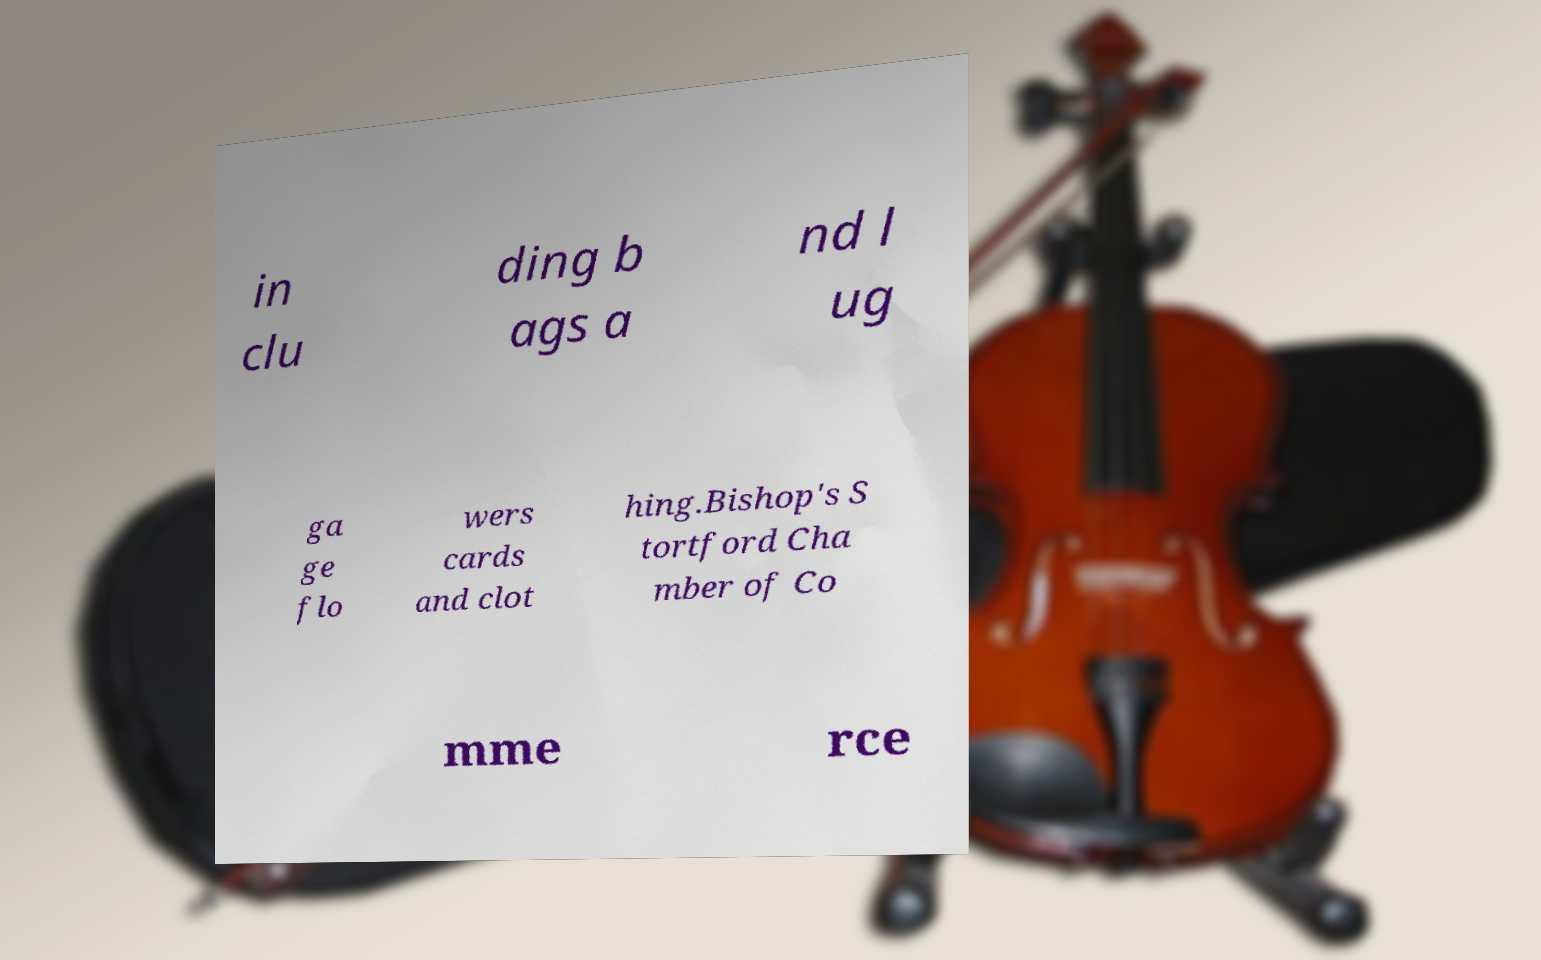Can you read and provide the text displayed in the image?This photo seems to have some interesting text. Can you extract and type it out for me? in clu ding b ags a nd l ug ga ge flo wers cards and clot hing.Bishop's S tortford Cha mber of Co mme rce 